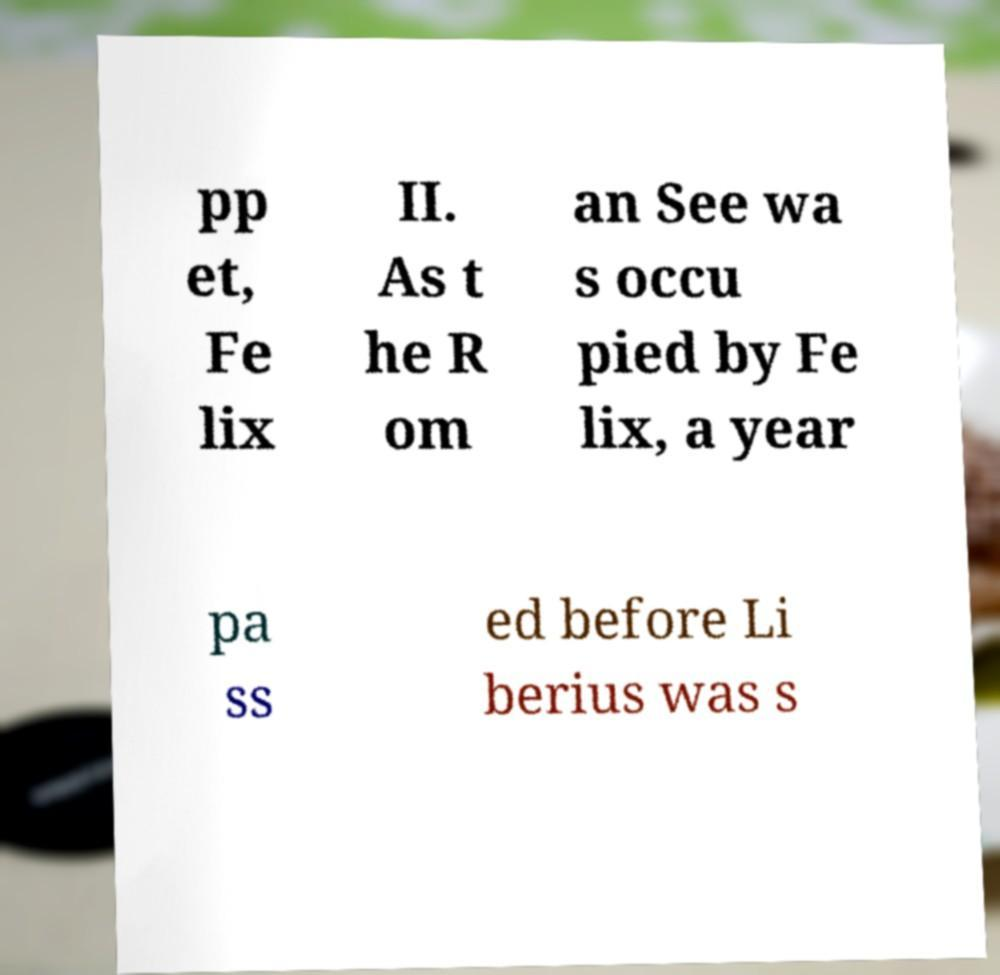Could you assist in decoding the text presented in this image and type it out clearly? pp et, Fe lix II. As t he R om an See wa s occu pied by Fe lix, a year pa ss ed before Li berius was s 